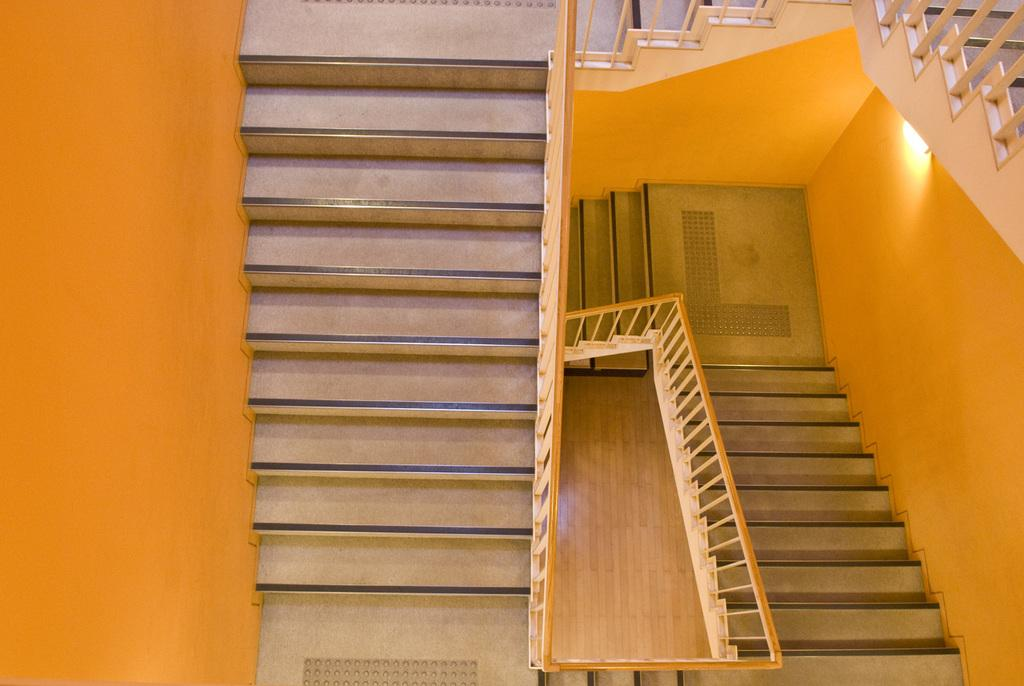What type of structure is visible in the image? There are stairs in the image. Can you describe the lighting in the image? There is a light in the image. What type of noise can be heard coming from the stairs in the image? There is no indication of any noise in the image, as it only features stairs and a light. 